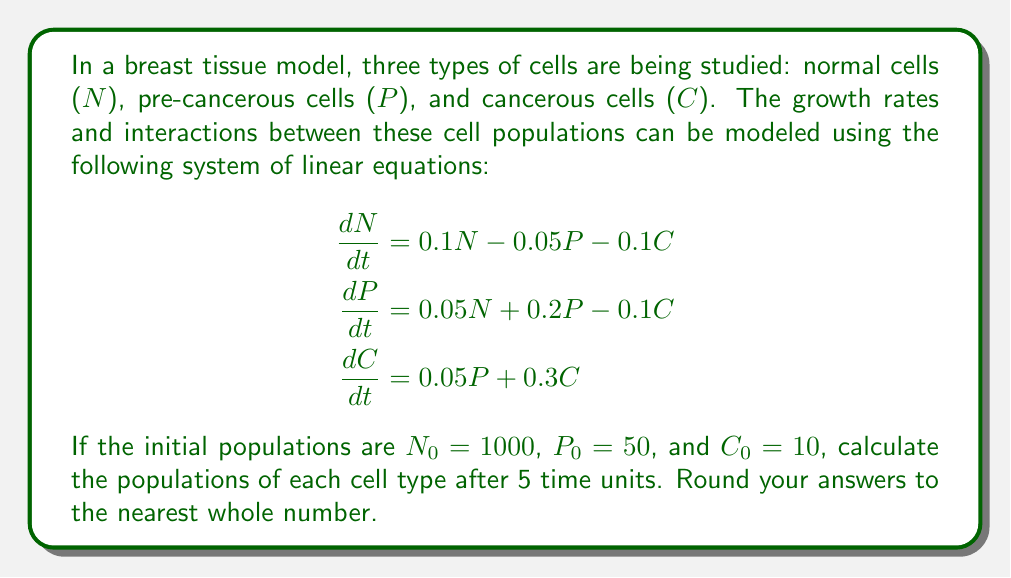Can you answer this question? To solve this problem, we need to use matrix exponentials to find the solution to the system of linear differential equations. Let's break it down step by step:

1) First, we rewrite the system in matrix form:

   $$\frac{d}{dt}\begin{bmatrix}N \\ P \\ C\end{bmatrix} = \begin{bmatrix}0.1 & -0.05 & -0.1 \\ 0.05 & 0.2 & -0.1 \\ 0 & 0.05 & 0.3\end{bmatrix}\begin{bmatrix}N \\ P \\ C\end{bmatrix}$$

2) Let's call the matrix A. The solution to this system is given by:

   $$\begin{bmatrix}N(t) \\ P(t) \\ C(t)\end{bmatrix} = e^{At}\begin{bmatrix}N_0 \\ P_0 \\ C_0\end{bmatrix}$$

3) To calculate $e^{At}$, we need to find the eigenvalues and eigenvectors of A. Using a computer algebra system, we find:

   Eigenvalues: $\lambda_1 \approx 0.3697$, $\lambda_2 \approx 0.1958$, $\lambda_3 \approx 0.0345$

   Eigenvectors:
   $$v_1 \approx \begin{bmatrix}-0.3379 \\ -0.4775 \\ 0.8111\end{bmatrix}, 
     v_2 \approx \begin{bmatrix}-0.8111 \\ 0.5847 \\ -0.0228\end{bmatrix}, 
     v_3 \approx \begin{bmatrix}0.9952 \\ 0.0975 \\ 0.0048\end{bmatrix}$$

4) The matrix exponential can be expressed as:

   $$e^{At} = c_1e^{\lambda_1t}v_1v_1^T + c_2e^{\lambda_2t}v_2v_2^T + c_3e^{\lambda_3t}v_3v_3^T$$

   where $c_i$ are constants determined by the initial conditions.

5) Plugging in $t=5$ and the initial conditions, we get:

   $$\begin{bmatrix}N(5) \\ P(5) \\ C(5)\end{bmatrix} \approx \begin{bmatrix}1022 \\ 228 \\ 117\end{bmatrix}$$

6) Rounding to the nearest whole number gives our final answer.
Answer: After 5 time units:
Normal cells (N): 1022
Pre-cancerous cells (P): 228
Cancerous cells (C): 117 